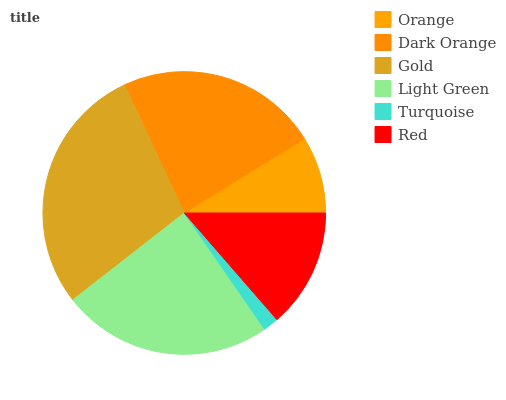Is Turquoise the minimum?
Answer yes or no. Yes. Is Gold the maximum?
Answer yes or no. Yes. Is Dark Orange the minimum?
Answer yes or no. No. Is Dark Orange the maximum?
Answer yes or no. No. Is Dark Orange greater than Orange?
Answer yes or no. Yes. Is Orange less than Dark Orange?
Answer yes or no. Yes. Is Orange greater than Dark Orange?
Answer yes or no. No. Is Dark Orange less than Orange?
Answer yes or no. No. Is Dark Orange the high median?
Answer yes or no. Yes. Is Red the low median?
Answer yes or no. Yes. Is Gold the high median?
Answer yes or no. No. Is Light Green the low median?
Answer yes or no. No. 